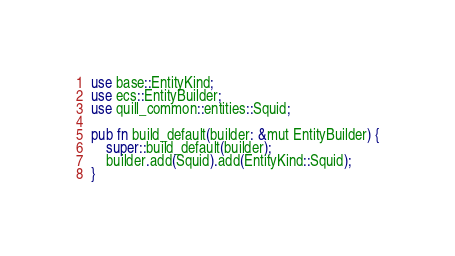<code> <loc_0><loc_0><loc_500><loc_500><_Rust_>use base::EntityKind;
use ecs::EntityBuilder;
use quill_common::entities::Squid;

pub fn build_default(builder: &mut EntityBuilder) {
    super::build_default(builder);
    builder.add(Squid).add(EntityKind::Squid);
}
</code> 